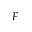<formula> <loc_0><loc_0><loc_500><loc_500>F</formula> 